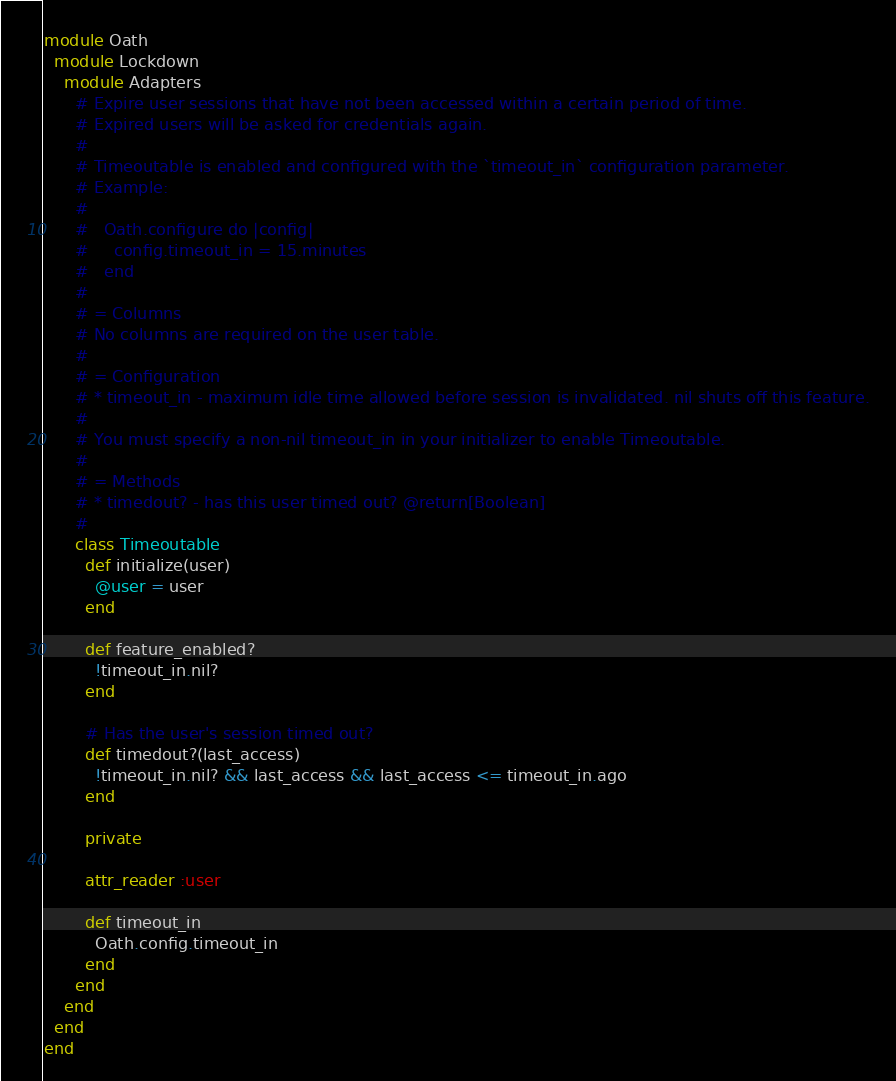Convert code to text. <code><loc_0><loc_0><loc_500><loc_500><_Ruby_>module Oath
  module Lockdown
    module Adapters
      # Expire user sessions that have not been accessed within a certain period of time.
      # Expired users will be asked for credentials again.
      #
      # Timeoutable is enabled and configured with the `timeout_in` configuration parameter.
      # Example:
      #
      #   Oath.configure do |config|
      #     config.timeout_in = 15.minutes
      #   end
      #
      # = Columns
      # No columns are required on the user table.
      #
      # = Configuration
      # * timeout_in - maximum idle time allowed before session is invalidated. nil shuts off this feature.
      #
      # You must specify a non-nil timeout_in in your initializer to enable Timeoutable.
      #
      # = Methods
      # * timedout? - has this user timed out? @return[Boolean]
      #
      class Timeoutable
        def initialize(user)
          @user = user
        end

        def feature_enabled?
          !timeout_in.nil?
        end

        # Has the user's session timed out?
        def timedout?(last_access)
          !timeout_in.nil? && last_access && last_access <= timeout_in.ago
        end

        private

        attr_reader :user

        def timeout_in
          Oath.config.timeout_in
        end
      end
    end
  end
end
</code> 